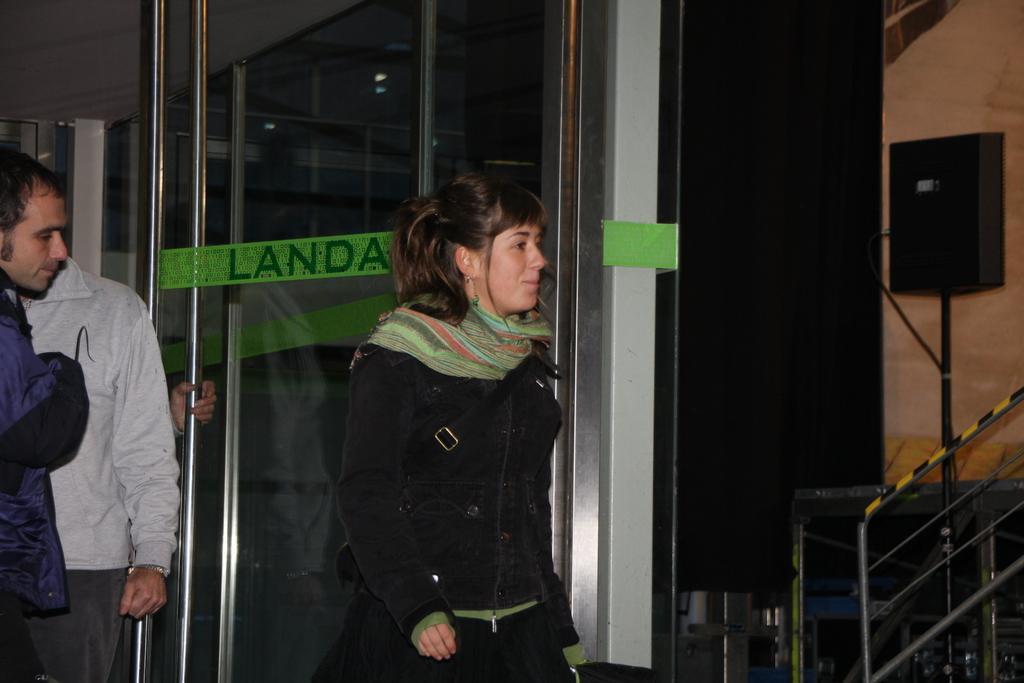Please provide a concise description of this image. In this image we can see one glass door, one green sticker with text attached to the glass door, one person hand holding a glass door handle, two men on the left side of the image, one barrier, one speaker with wire attached to the pole, we can see the reflection of lights in the glass door, the background is dark, some objects near the wall on the right side of the image, one woman walking wearing a bag and holding an object in the middle of the image. 